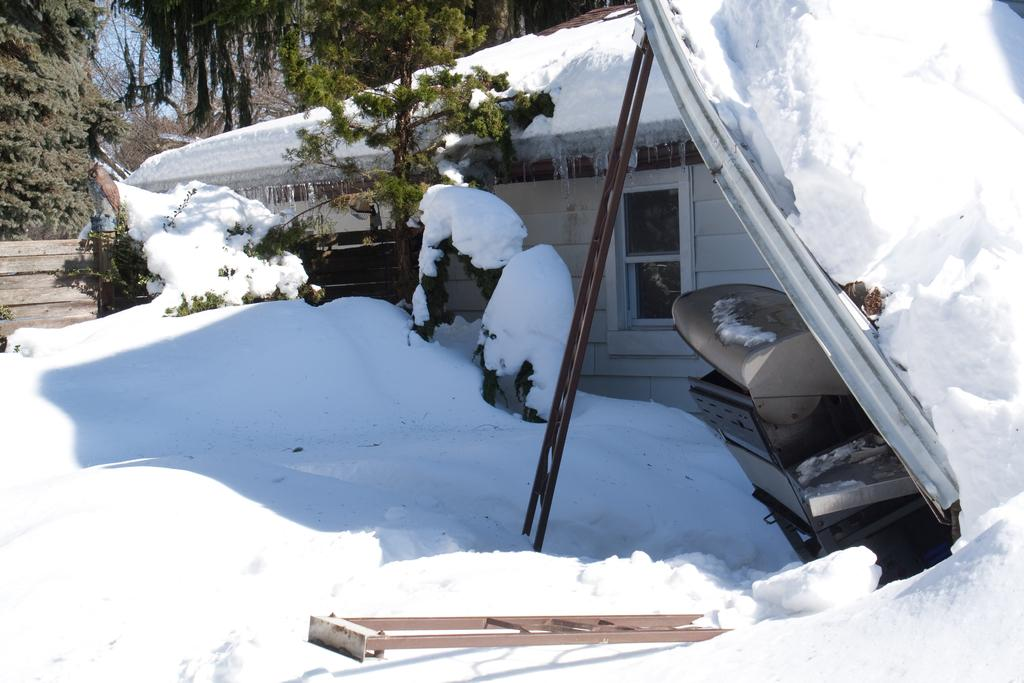What type of environment is depicted in the image? The image is an outdoor scene. What is the condition of the land in the image? The land is covered with snow. What structure can be seen in the image? There is a house in the image. What feature of the house is visible in the image? The house has a window. What can be seen in the distance in the image? There are trees in the distance. What object is present in the image that might be used for climbing or reaching higher places? There is a ladder in the image. What type of pump is visible in the image? There is no pump present in the image. What kind of vessel is being used to transport the snow in the image? There is no vessel or snow transportation activity depicted in the image. 